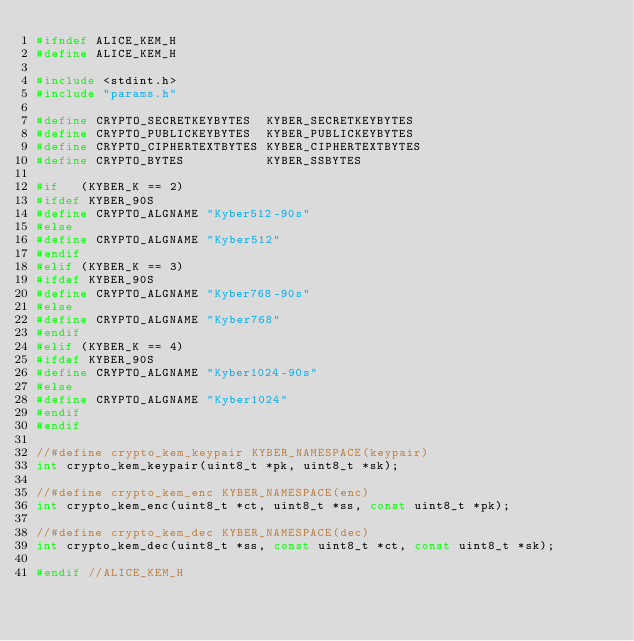Convert code to text. <code><loc_0><loc_0><loc_500><loc_500><_C_>#ifndef ALICE_KEM_H
#define ALICE_KEM_H

#include <stdint.h>
#include "params.h"

#define CRYPTO_SECRETKEYBYTES  KYBER_SECRETKEYBYTES
#define CRYPTO_PUBLICKEYBYTES  KYBER_PUBLICKEYBYTES
#define CRYPTO_CIPHERTEXTBYTES KYBER_CIPHERTEXTBYTES
#define CRYPTO_BYTES           KYBER_SSBYTES

#if   (KYBER_K == 2)
#ifdef KYBER_90S
#define CRYPTO_ALGNAME "Kyber512-90s"
#else
#define CRYPTO_ALGNAME "Kyber512"
#endif
#elif (KYBER_K == 3)
#ifdef KYBER_90S
#define CRYPTO_ALGNAME "Kyber768-90s"
#else
#define CRYPTO_ALGNAME "Kyber768"
#endif
#elif (KYBER_K == 4)
#ifdef KYBER_90S
#define CRYPTO_ALGNAME "Kyber1024-90s"
#else
#define CRYPTO_ALGNAME "Kyber1024"
#endif
#endif

//#define crypto_kem_keypair KYBER_NAMESPACE(keypair)
int crypto_kem_keypair(uint8_t *pk, uint8_t *sk);

//#define crypto_kem_enc KYBER_NAMESPACE(enc)
int crypto_kem_enc(uint8_t *ct, uint8_t *ss, const uint8_t *pk);

//#define crypto_kem_dec KYBER_NAMESPACE(dec)
int crypto_kem_dec(uint8_t *ss, const uint8_t *ct, const uint8_t *sk);

#endif //ALICE_KEM_H
</code> 